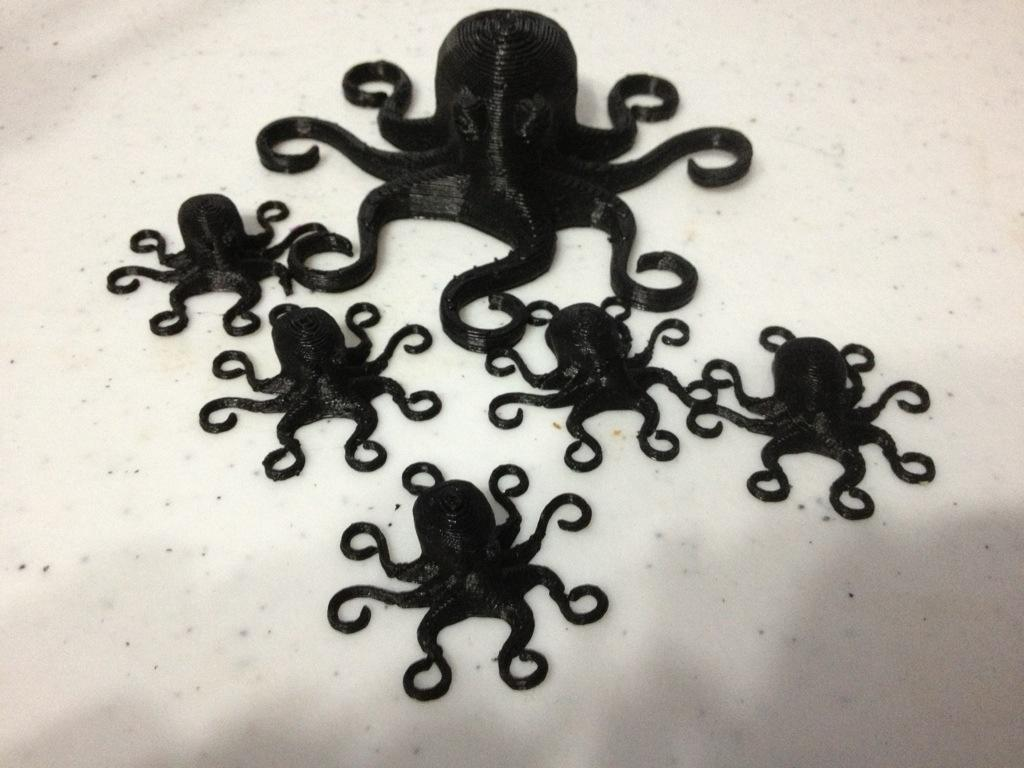What is the main subject of the image? There is a white object in the image, possibly a cake. What decorations are present on the white object? There are octopuses made with cream in the middle of the image. What color are the octopuses? The octopuses are black in color. Where is the grandmother sitting in the image? There is no grandmother present in the image. Can you describe the feather used to decorate the cake in the image? There is no feather mentioned or visible in the image. 